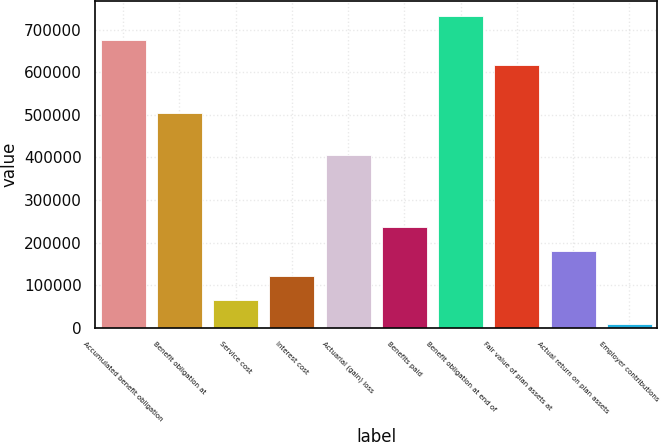Convert chart to OTSL. <chart><loc_0><loc_0><loc_500><loc_500><bar_chart><fcel>Accumulated benefit obligation<fcel>Benefit obligation at<fcel>Service cost<fcel>Interest cost<fcel>Actuarial (gain) loss<fcel>Benefits paid<fcel>Benefit obligation at end of<fcel>Fair value of plan assets at<fcel>Actual return on plan assets<fcel>Employer contributions<nl><fcel>675350<fcel>504719<fcel>65377<fcel>122254<fcel>406639<fcel>236008<fcel>732227<fcel>618473<fcel>179131<fcel>8500<nl></chart> 